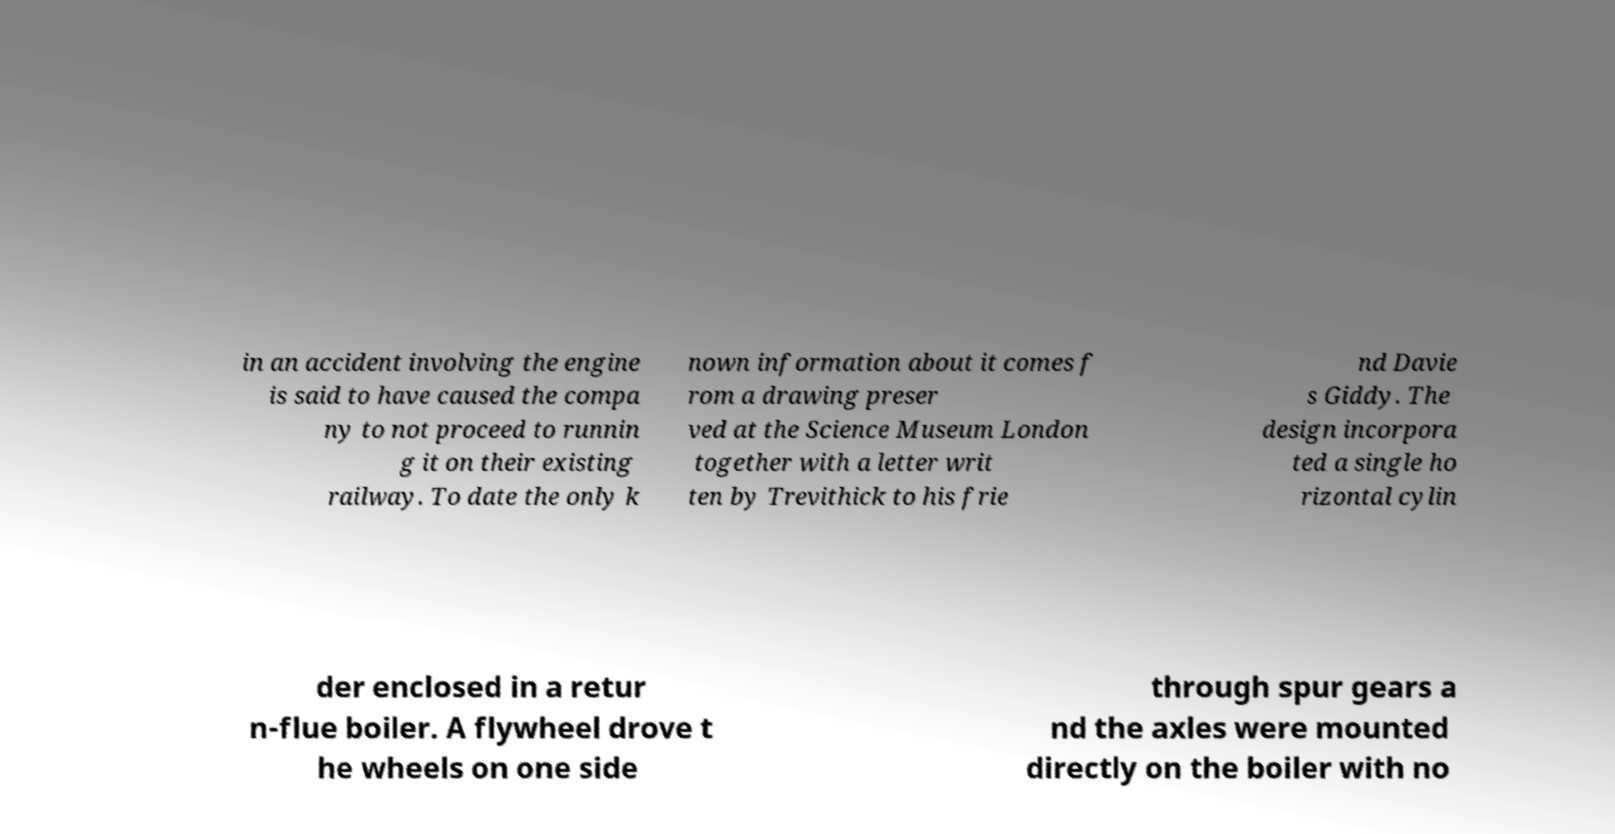Please identify and transcribe the text found in this image. in an accident involving the engine is said to have caused the compa ny to not proceed to runnin g it on their existing railway. To date the only k nown information about it comes f rom a drawing preser ved at the Science Museum London together with a letter writ ten by Trevithick to his frie nd Davie s Giddy. The design incorpora ted a single ho rizontal cylin der enclosed in a retur n-flue boiler. A flywheel drove t he wheels on one side through spur gears a nd the axles were mounted directly on the boiler with no 